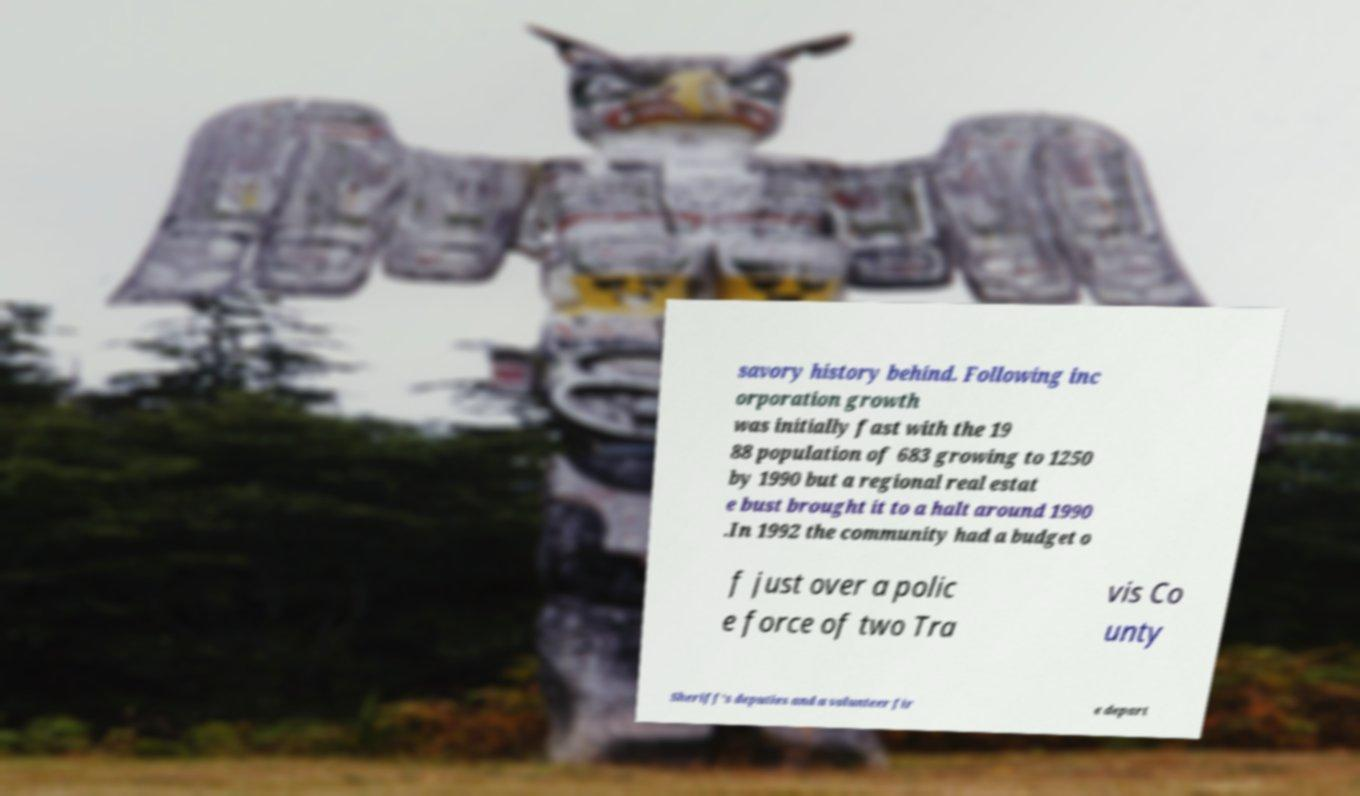Can you accurately transcribe the text from the provided image for me? savory history behind. Following inc orporation growth was initially fast with the 19 88 population of 683 growing to 1250 by 1990 but a regional real estat e bust brought it to a halt around 1990 .In 1992 the community had a budget o f just over a polic e force of two Tra vis Co unty Sheriff's deputies and a volunteer fir e depart 